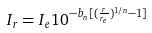Convert formula to latex. <formula><loc_0><loc_0><loc_500><loc_500>I _ { r } = I _ { e } 1 0 ^ { - b _ { n } [ ( \frac { r } { r _ { e } } ) ^ { 1 / n } - 1 ] }</formula> 